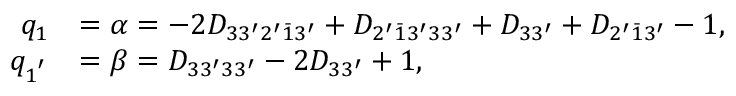<formula> <loc_0><loc_0><loc_500><loc_500>\begin{array} { r l } { q _ { 1 } } & { = \alpha = - 2 { D _ { 3 3 ^ { \prime } 2 ^ { \prime } \bar { 1 } 3 ^ { \prime } } } + { D _ { 2 ^ { \prime } \bar { 1 } 3 ^ { \prime } 3 3 ^ { \prime } } } + { D _ { 3 3 ^ { \prime } } } + { D _ { 2 ^ { \prime } \bar { 1 } 3 ^ { \prime } } } - 1 , } \\ { q _ { 1 ^ { ^ { \prime } } } } & { = \beta = { D _ { 3 3 ^ { \prime } 3 3 ^ { \prime } } } - 2 { D _ { 3 3 ^ { \prime } } } + 1 , } \end{array}</formula> 